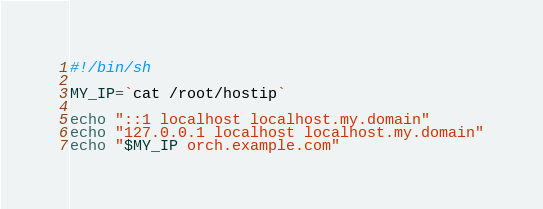Convert code to text. <code><loc_0><loc_0><loc_500><loc_500><_Bash_>#!/bin/sh

MY_IP=`cat /root/hostip`

echo "::1 localhost localhost.my.domain"
echo "127.0.0.1 localhost localhost.my.domain"
echo "$MY_IP orch.example.com"
</code> 